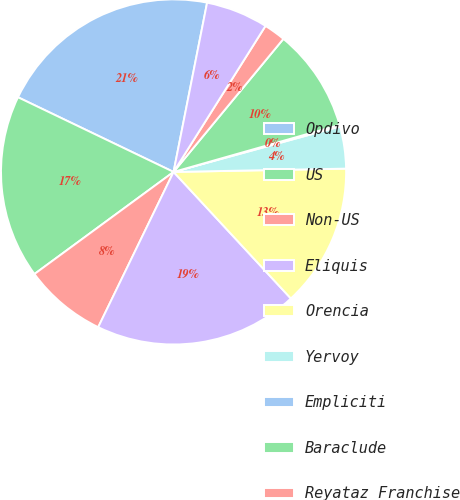Convert chart. <chart><loc_0><loc_0><loc_500><loc_500><pie_chart><fcel>Opdivo<fcel>US<fcel>Non-US<fcel>Eliquis<fcel>Orencia<fcel>Yervoy<fcel>Empliciti<fcel>Baraclude<fcel>Reyataz Franchise<fcel>Sustiva Franchise<nl><fcel>20.99%<fcel>17.2%<fcel>7.73%<fcel>19.09%<fcel>13.41%<fcel>3.94%<fcel>0.15%<fcel>9.62%<fcel>2.04%<fcel>5.83%<nl></chart> 